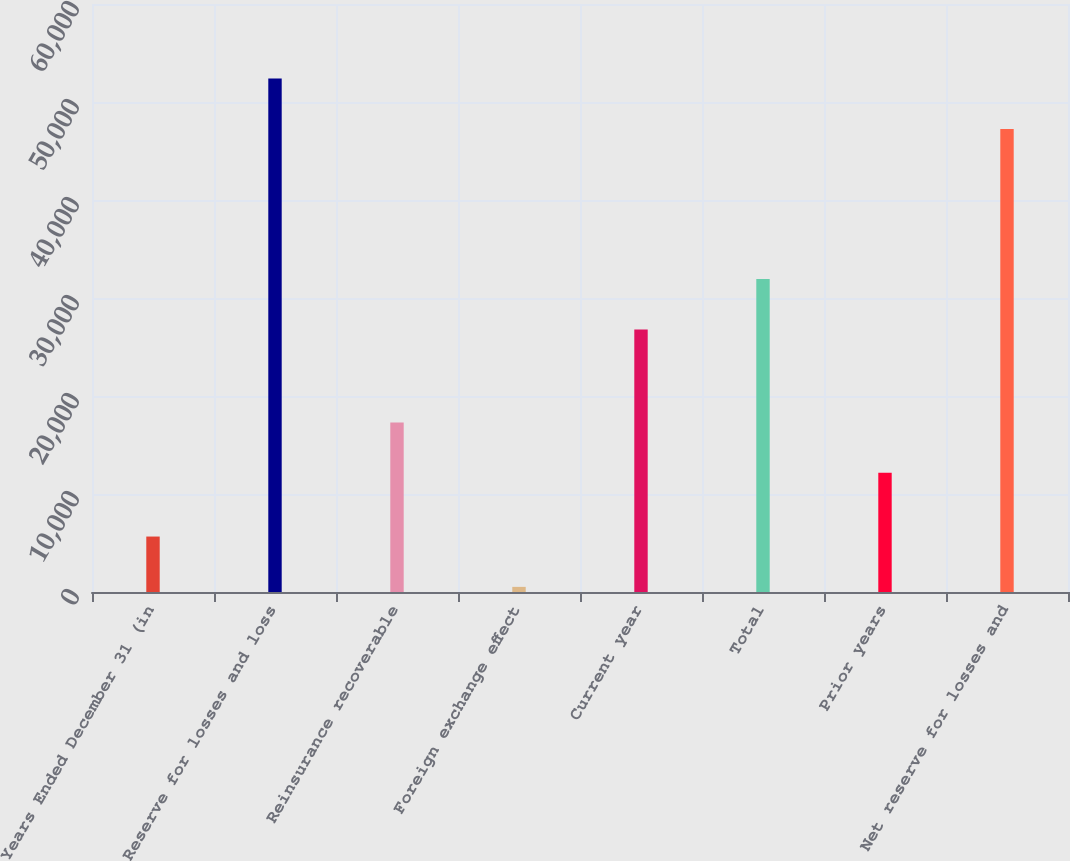Convert chart. <chart><loc_0><loc_0><loc_500><loc_500><bar_chart><fcel>Years Ended December 31 (in<fcel>Reserve for losses and loss<fcel>Reinsurance recoverable<fcel>Foreign exchange effect<fcel>Current year<fcel>Total<fcel>Prior years<fcel>Net reserve for losses and<nl><fcel>5658.7<fcel>52388.7<fcel>17297.7<fcel>524<fcel>26793<fcel>31927.7<fcel>12163<fcel>47254<nl></chart> 